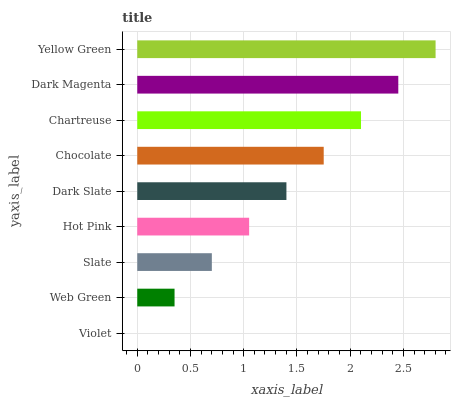Is Violet the minimum?
Answer yes or no. Yes. Is Yellow Green the maximum?
Answer yes or no. Yes. Is Web Green the minimum?
Answer yes or no. No. Is Web Green the maximum?
Answer yes or no. No. Is Web Green greater than Violet?
Answer yes or no. Yes. Is Violet less than Web Green?
Answer yes or no. Yes. Is Violet greater than Web Green?
Answer yes or no. No. Is Web Green less than Violet?
Answer yes or no. No. Is Dark Slate the high median?
Answer yes or no. Yes. Is Dark Slate the low median?
Answer yes or no. Yes. Is Chartreuse the high median?
Answer yes or no. No. Is Dark Magenta the low median?
Answer yes or no. No. 